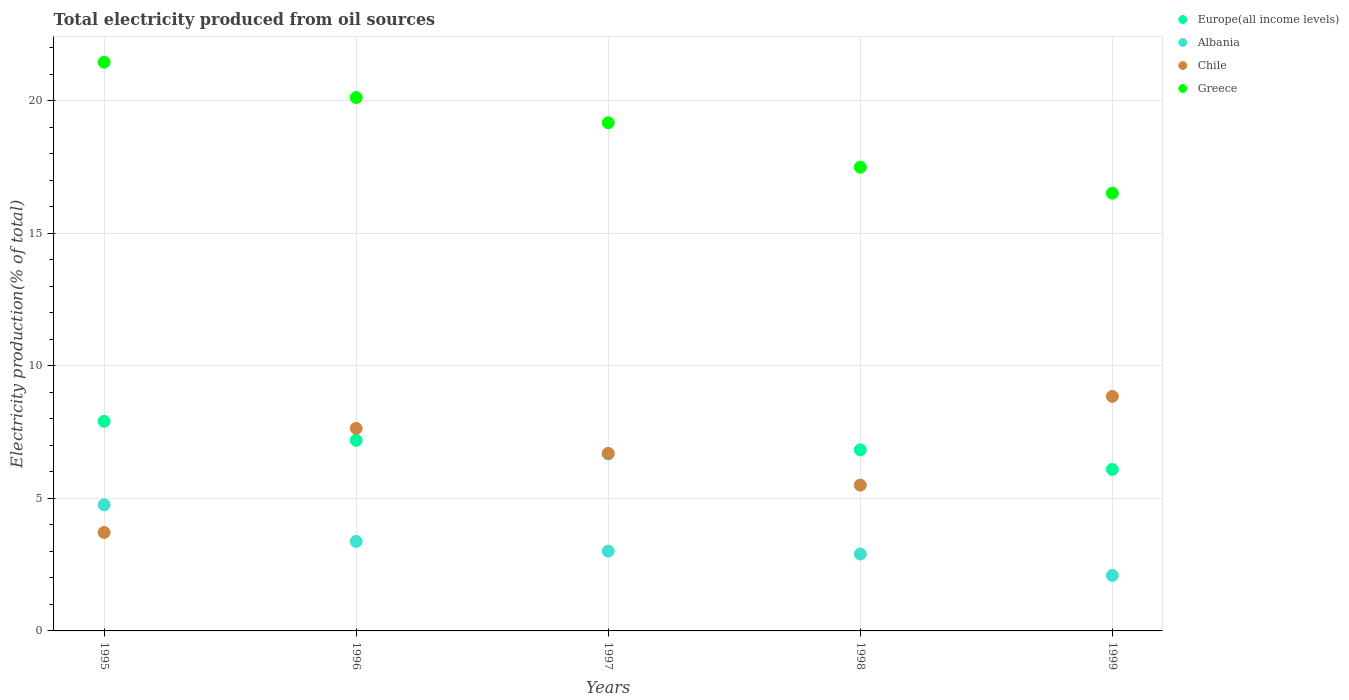Is the number of dotlines equal to the number of legend labels?
Offer a terse response. Yes. What is the total electricity produced in Albania in 1999?
Keep it short and to the point. 2.09. Across all years, what is the maximum total electricity produced in Greece?
Offer a terse response. 21.45. Across all years, what is the minimum total electricity produced in Europe(all income levels)?
Provide a succinct answer. 6.09. In which year was the total electricity produced in Chile minimum?
Offer a very short reply. 1995. What is the total total electricity produced in Albania in the graph?
Your answer should be very brief. 16.14. What is the difference between the total electricity produced in Greece in 1995 and that in 1997?
Ensure brevity in your answer.  2.28. What is the difference between the total electricity produced in Albania in 1998 and the total electricity produced in Europe(all income levels) in 1999?
Your response must be concise. -3.19. What is the average total electricity produced in Chile per year?
Your response must be concise. 6.48. In the year 1998, what is the difference between the total electricity produced in Greece and total electricity produced in Albania?
Make the answer very short. 14.59. In how many years, is the total electricity produced in Chile greater than 16 %?
Keep it short and to the point. 0. What is the ratio of the total electricity produced in Greece in 1995 to that in 1996?
Your answer should be compact. 1.07. Is the difference between the total electricity produced in Greece in 1995 and 1996 greater than the difference between the total electricity produced in Albania in 1995 and 1996?
Your answer should be compact. No. What is the difference between the highest and the second highest total electricity produced in Europe(all income levels)?
Provide a short and direct response. 0.72. What is the difference between the highest and the lowest total electricity produced in Albania?
Ensure brevity in your answer.  2.66. Is the sum of the total electricity produced in Albania in 1998 and 1999 greater than the maximum total electricity produced in Greece across all years?
Provide a short and direct response. No. Is it the case that in every year, the sum of the total electricity produced in Albania and total electricity produced in Europe(all income levels)  is greater than the total electricity produced in Chile?
Offer a very short reply. No. Is the total electricity produced in Albania strictly less than the total electricity produced in Chile over the years?
Give a very brief answer. No. How many dotlines are there?
Ensure brevity in your answer.  4. Does the graph contain grids?
Offer a terse response. Yes. How many legend labels are there?
Your answer should be very brief. 4. How are the legend labels stacked?
Your answer should be compact. Vertical. What is the title of the graph?
Provide a short and direct response. Total electricity produced from oil sources. Does "Tonga" appear as one of the legend labels in the graph?
Your answer should be very brief. No. What is the label or title of the Y-axis?
Give a very brief answer. Electricity production(% of total). What is the Electricity production(% of total) of Europe(all income levels) in 1995?
Make the answer very short. 7.91. What is the Electricity production(% of total) in Albania in 1995?
Your answer should be very brief. 4.76. What is the Electricity production(% of total) of Chile in 1995?
Ensure brevity in your answer.  3.71. What is the Electricity production(% of total) of Greece in 1995?
Provide a succinct answer. 21.45. What is the Electricity production(% of total) of Europe(all income levels) in 1996?
Make the answer very short. 7.19. What is the Electricity production(% of total) of Albania in 1996?
Keep it short and to the point. 3.37. What is the Electricity production(% of total) of Chile in 1996?
Offer a very short reply. 7.64. What is the Electricity production(% of total) in Greece in 1996?
Offer a terse response. 20.12. What is the Electricity production(% of total) of Europe(all income levels) in 1997?
Your response must be concise. 6.68. What is the Electricity production(% of total) of Albania in 1997?
Ensure brevity in your answer.  3.01. What is the Electricity production(% of total) in Chile in 1997?
Offer a very short reply. 6.7. What is the Electricity production(% of total) in Greece in 1997?
Offer a very short reply. 19.17. What is the Electricity production(% of total) of Europe(all income levels) in 1998?
Offer a very short reply. 6.83. What is the Electricity production(% of total) in Albania in 1998?
Keep it short and to the point. 2.9. What is the Electricity production(% of total) of Chile in 1998?
Offer a very short reply. 5.5. What is the Electricity production(% of total) of Greece in 1998?
Make the answer very short. 17.49. What is the Electricity production(% of total) in Europe(all income levels) in 1999?
Your answer should be very brief. 6.09. What is the Electricity production(% of total) in Albania in 1999?
Ensure brevity in your answer.  2.09. What is the Electricity production(% of total) in Chile in 1999?
Keep it short and to the point. 8.85. What is the Electricity production(% of total) in Greece in 1999?
Provide a short and direct response. 16.51. Across all years, what is the maximum Electricity production(% of total) in Europe(all income levels)?
Make the answer very short. 7.91. Across all years, what is the maximum Electricity production(% of total) of Albania?
Your answer should be very brief. 4.76. Across all years, what is the maximum Electricity production(% of total) of Chile?
Offer a terse response. 8.85. Across all years, what is the maximum Electricity production(% of total) in Greece?
Ensure brevity in your answer.  21.45. Across all years, what is the minimum Electricity production(% of total) in Europe(all income levels)?
Ensure brevity in your answer.  6.09. Across all years, what is the minimum Electricity production(% of total) in Albania?
Offer a terse response. 2.09. Across all years, what is the minimum Electricity production(% of total) in Chile?
Make the answer very short. 3.71. Across all years, what is the minimum Electricity production(% of total) of Greece?
Give a very brief answer. 16.51. What is the total Electricity production(% of total) in Europe(all income levels) in the graph?
Ensure brevity in your answer.  34.7. What is the total Electricity production(% of total) of Albania in the graph?
Offer a terse response. 16.14. What is the total Electricity production(% of total) of Chile in the graph?
Your response must be concise. 32.4. What is the total Electricity production(% of total) in Greece in the graph?
Your answer should be compact. 94.75. What is the difference between the Electricity production(% of total) of Europe(all income levels) in 1995 and that in 1996?
Give a very brief answer. 0.72. What is the difference between the Electricity production(% of total) of Albania in 1995 and that in 1996?
Ensure brevity in your answer.  1.38. What is the difference between the Electricity production(% of total) of Chile in 1995 and that in 1996?
Keep it short and to the point. -3.93. What is the difference between the Electricity production(% of total) in Greece in 1995 and that in 1996?
Ensure brevity in your answer.  1.33. What is the difference between the Electricity production(% of total) of Europe(all income levels) in 1995 and that in 1997?
Offer a very short reply. 1.22. What is the difference between the Electricity production(% of total) in Albania in 1995 and that in 1997?
Keep it short and to the point. 1.75. What is the difference between the Electricity production(% of total) in Chile in 1995 and that in 1997?
Your answer should be compact. -2.98. What is the difference between the Electricity production(% of total) in Greece in 1995 and that in 1997?
Your answer should be compact. 2.28. What is the difference between the Electricity production(% of total) in Europe(all income levels) in 1995 and that in 1998?
Ensure brevity in your answer.  1.08. What is the difference between the Electricity production(% of total) of Albania in 1995 and that in 1998?
Your answer should be very brief. 1.86. What is the difference between the Electricity production(% of total) in Chile in 1995 and that in 1998?
Provide a succinct answer. -1.79. What is the difference between the Electricity production(% of total) in Greece in 1995 and that in 1998?
Offer a very short reply. 3.96. What is the difference between the Electricity production(% of total) of Europe(all income levels) in 1995 and that in 1999?
Your answer should be very brief. 1.82. What is the difference between the Electricity production(% of total) of Albania in 1995 and that in 1999?
Ensure brevity in your answer.  2.66. What is the difference between the Electricity production(% of total) of Chile in 1995 and that in 1999?
Offer a very short reply. -5.13. What is the difference between the Electricity production(% of total) in Greece in 1995 and that in 1999?
Your answer should be compact. 4.94. What is the difference between the Electricity production(% of total) in Europe(all income levels) in 1996 and that in 1997?
Your answer should be compact. 0.51. What is the difference between the Electricity production(% of total) in Albania in 1996 and that in 1997?
Your answer should be compact. 0.37. What is the difference between the Electricity production(% of total) in Chile in 1996 and that in 1997?
Your answer should be compact. 0.94. What is the difference between the Electricity production(% of total) of Greece in 1996 and that in 1997?
Your response must be concise. 0.95. What is the difference between the Electricity production(% of total) of Europe(all income levels) in 1996 and that in 1998?
Ensure brevity in your answer.  0.36. What is the difference between the Electricity production(% of total) of Albania in 1996 and that in 1998?
Offer a terse response. 0.47. What is the difference between the Electricity production(% of total) in Chile in 1996 and that in 1998?
Give a very brief answer. 2.14. What is the difference between the Electricity production(% of total) in Greece in 1996 and that in 1998?
Your answer should be very brief. 2.63. What is the difference between the Electricity production(% of total) in Europe(all income levels) in 1996 and that in 1999?
Your answer should be very brief. 1.1. What is the difference between the Electricity production(% of total) in Albania in 1996 and that in 1999?
Your answer should be compact. 1.28. What is the difference between the Electricity production(% of total) of Chile in 1996 and that in 1999?
Keep it short and to the point. -1.21. What is the difference between the Electricity production(% of total) of Greece in 1996 and that in 1999?
Your answer should be very brief. 3.61. What is the difference between the Electricity production(% of total) of Europe(all income levels) in 1997 and that in 1998?
Your response must be concise. -0.15. What is the difference between the Electricity production(% of total) of Albania in 1997 and that in 1998?
Your answer should be very brief. 0.11. What is the difference between the Electricity production(% of total) in Chile in 1997 and that in 1998?
Your answer should be very brief. 1.2. What is the difference between the Electricity production(% of total) of Greece in 1997 and that in 1998?
Offer a terse response. 1.68. What is the difference between the Electricity production(% of total) in Europe(all income levels) in 1997 and that in 1999?
Make the answer very short. 0.59. What is the difference between the Electricity production(% of total) in Albania in 1997 and that in 1999?
Ensure brevity in your answer.  0.92. What is the difference between the Electricity production(% of total) in Chile in 1997 and that in 1999?
Ensure brevity in your answer.  -2.15. What is the difference between the Electricity production(% of total) in Greece in 1997 and that in 1999?
Your answer should be very brief. 2.66. What is the difference between the Electricity production(% of total) in Europe(all income levels) in 1998 and that in 1999?
Your answer should be compact. 0.74. What is the difference between the Electricity production(% of total) in Albania in 1998 and that in 1999?
Provide a succinct answer. 0.81. What is the difference between the Electricity production(% of total) of Chile in 1998 and that in 1999?
Your answer should be very brief. -3.35. What is the difference between the Electricity production(% of total) in Greece in 1998 and that in 1999?
Provide a short and direct response. 0.98. What is the difference between the Electricity production(% of total) of Europe(all income levels) in 1995 and the Electricity production(% of total) of Albania in 1996?
Provide a succinct answer. 4.53. What is the difference between the Electricity production(% of total) in Europe(all income levels) in 1995 and the Electricity production(% of total) in Chile in 1996?
Make the answer very short. 0.27. What is the difference between the Electricity production(% of total) of Europe(all income levels) in 1995 and the Electricity production(% of total) of Greece in 1996?
Your response must be concise. -12.22. What is the difference between the Electricity production(% of total) in Albania in 1995 and the Electricity production(% of total) in Chile in 1996?
Make the answer very short. -2.88. What is the difference between the Electricity production(% of total) in Albania in 1995 and the Electricity production(% of total) in Greece in 1996?
Your answer should be compact. -15.36. What is the difference between the Electricity production(% of total) of Chile in 1995 and the Electricity production(% of total) of Greece in 1996?
Your response must be concise. -16.41. What is the difference between the Electricity production(% of total) in Europe(all income levels) in 1995 and the Electricity production(% of total) in Albania in 1997?
Offer a terse response. 4.9. What is the difference between the Electricity production(% of total) of Europe(all income levels) in 1995 and the Electricity production(% of total) of Chile in 1997?
Your response must be concise. 1.21. What is the difference between the Electricity production(% of total) of Europe(all income levels) in 1995 and the Electricity production(% of total) of Greece in 1997?
Keep it short and to the point. -11.26. What is the difference between the Electricity production(% of total) of Albania in 1995 and the Electricity production(% of total) of Chile in 1997?
Provide a short and direct response. -1.94. What is the difference between the Electricity production(% of total) in Albania in 1995 and the Electricity production(% of total) in Greece in 1997?
Make the answer very short. -14.41. What is the difference between the Electricity production(% of total) in Chile in 1995 and the Electricity production(% of total) in Greece in 1997?
Make the answer very short. -15.46. What is the difference between the Electricity production(% of total) of Europe(all income levels) in 1995 and the Electricity production(% of total) of Albania in 1998?
Your answer should be very brief. 5.01. What is the difference between the Electricity production(% of total) of Europe(all income levels) in 1995 and the Electricity production(% of total) of Chile in 1998?
Give a very brief answer. 2.41. What is the difference between the Electricity production(% of total) of Europe(all income levels) in 1995 and the Electricity production(% of total) of Greece in 1998?
Provide a succinct answer. -9.59. What is the difference between the Electricity production(% of total) of Albania in 1995 and the Electricity production(% of total) of Chile in 1998?
Ensure brevity in your answer.  -0.74. What is the difference between the Electricity production(% of total) in Albania in 1995 and the Electricity production(% of total) in Greece in 1998?
Your response must be concise. -12.73. What is the difference between the Electricity production(% of total) of Chile in 1995 and the Electricity production(% of total) of Greece in 1998?
Ensure brevity in your answer.  -13.78. What is the difference between the Electricity production(% of total) in Europe(all income levels) in 1995 and the Electricity production(% of total) in Albania in 1999?
Make the answer very short. 5.81. What is the difference between the Electricity production(% of total) in Europe(all income levels) in 1995 and the Electricity production(% of total) in Chile in 1999?
Provide a succinct answer. -0.94. What is the difference between the Electricity production(% of total) in Europe(all income levels) in 1995 and the Electricity production(% of total) in Greece in 1999?
Give a very brief answer. -8.61. What is the difference between the Electricity production(% of total) of Albania in 1995 and the Electricity production(% of total) of Chile in 1999?
Ensure brevity in your answer.  -4.09. What is the difference between the Electricity production(% of total) in Albania in 1995 and the Electricity production(% of total) in Greece in 1999?
Give a very brief answer. -11.76. What is the difference between the Electricity production(% of total) of Chile in 1995 and the Electricity production(% of total) of Greece in 1999?
Offer a terse response. -12.8. What is the difference between the Electricity production(% of total) of Europe(all income levels) in 1996 and the Electricity production(% of total) of Albania in 1997?
Your answer should be very brief. 4.18. What is the difference between the Electricity production(% of total) in Europe(all income levels) in 1996 and the Electricity production(% of total) in Chile in 1997?
Give a very brief answer. 0.49. What is the difference between the Electricity production(% of total) of Europe(all income levels) in 1996 and the Electricity production(% of total) of Greece in 1997?
Keep it short and to the point. -11.98. What is the difference between the Electricity production(% of total) of Albania in 1996 and the Electricity production(% of total) of Chile in 1997?
Offer a terse response. -3.32. What is the difference between the Electricity production(% of total) of Albania in 1996 and the Electricity production(% of total) of Greece in 1997?
Offer a terse response. -15.79. What is the difference between the Electricity production(% of total) in Chile in 1996 and the Electricity production(% of total) in Greece in 1997?
Keep it short and to the point. -11.53. What is the difference between the Electricity production(% of total) of Europe(all income levels) in 1996 and the Electricity production(% of total) of Albania in 1998?
Provide a succinct answer. 4.29. What is the difference between the Electricity production(% of total) of Europe(all income levels) in 1996 and the Electricity production(% of total) of Chile in 1998?
Offer a very short reply. 1.69. What is the difference between the Electricity production(% of total) in Europe(all income levels) in 1996 and the Electricity production(% of total) in Greece in 1998?
Your answer should be very brief. -10.3. What is the difference between the Electricity production(% of total) of Albania in 1996 and the Electricity production(% of total) of Chile in 1998?
Offer a very short reply. -2.13. What is the difference between the Electricity production(% of total) in Albania in 1996 and the Electricity production(% of total) in Greece in 1998?
Your answer should be compact. -14.12. What is the difference between the Electricity production(% of total) in Chile in 1996 and the Electricity production(% of total) in Greece in 1998?
Make the answer very short. -9.85. What is the difference between the Electricity production(% of total) in Europe(all income levels) in 1996 and the Electricity production(% of total) in Albania in 1999?
Offer a very short reply. 5.1. What is the difference between the Electricity production(% of total) of Europe(all income levels) in 1996 and the Electricity production(% of total) of Chile in 1999?
Offer a very short reply. -1.66. What is the difference between the Electricity production(% of total) of Europe(all income levels) in 1996 and the Electricity production(% of total) of Greece in 1999?
Your answer should be very brief. -9.32. What is the difference between the Electricity production(% of total) of Albania in 1996 and the Electricity production(% of total) of Chile in 1999?
Your answer should be compact. -5.47. What is the difference between the Electricity production(% of total) in Albania in 1996 and the Electricity production(% of total) in Greece in 1999?
Provide a short and direct response. -13.14. What is the difference between the Electricity production(% of total) of Chile in 1996 and the Electricity production(% of total) of Greece in 1999?
Your answer should be very brief. -8.87. What is the difference between the Electricity production(% of total) of Europe(all income levels) in 1997 and the Electricity production(% of total) of Albania in 1998?
Ensure brevity in your answer.  3.78. What is the difference between the Electricity production(% of total) of Europe(all income levels) in 1997 and the Electricity production(% of total) of Chile in 1998?
Ensure brevity in your answer.  1.18. What is the difference between the Electricity production(% of total) in Europe(all income levels) in 1997 and the Electricity production(% of total) in Greece in 1998?
Your answer should be very brief. -10.81. What is the difference between the Electricity production(% of total) of Albania in 1997 and the Electricity production(% of total) of Chile in 1998?
Ensure brevity in your answer.  -2.49. What is the difference between the Electricity production(% of total) of Albania in 1997 and the Electricity production(% of total) of Greece in 1998?
Make the answer very short. -14.48. What is the difference between the Electricity production(% of total) of Chile in 1997 and the Electricity production(% of total) of Greece in 1998?
Offer a very short reply. -10.8. What is the difference between the Electricity production(% of total) of Europe(all income levels) in 1997 and the Electricity production(% of total) of Albania in 1999?
Offer a very short reply. 4.59. What is the difference between the Electricity production(% of total) in Europe(all income levels) in 1997 and the Electricity production(% of total) in Chile in 1999?
Offer a very short reply. -2.17. What is the difference between the Electricity production(% of total) of Europe(all income levels) in 1997 and the Electricity production(% of total) of Greece in 1999?
Provide a succinct answer. -9.83. What is the difference between the Electricity production(% of total) of Albania in 1997 and the Electricity production(% of total) of Chile in 1999?
Your answer should be compact. -5.84. What is the difference between the Electricity production(% of total) in Albania in 1997 and the Electricity production(% of total) in Greece in 1999?
Offer a terse response. -13.5. What is the difference between the Electricity production(% of total) in Chile in 1997 and the Electricity production(% of total) in Greece in 1999?
Give a very brief answer. -9.82. What is the difference between the Electricity production(% of total) in Europe(all income levels) in 1998 and the Electricity production(% of total) in Albania in 1999?
Keep it short and to the point. 4.74. What is the difference between the Electricity production(% of total) of Europe(all income levels) in 1998 and the Electricity production(% of total) of Chile in 1999?
Your response must be concise. -2.02. What is the difference between the Electricity production(% of total) in Europe(all income levels) in 1998 and the Electricity production(% of total) in Greece in 1999?
Your response must be concise. -9.68. What is the difference between the Electricity production(% of total) in Albania in 1998 and the Electricity production(% of total) in Chile in 1999?
Your answer should be very brief. -5.95. What is the difference between the Electricity production(% of total) of Albania in 1998 and the Electricity production(% of total) of Greece in 1999?
Provide a succinct answer. -13.61. What is the difference between the Electricity production(% of total) in Chile in 1998 and the Electricity production(% of total) in Greece in 1999?
Your answer should be very brief. -11.01. What is the average Electricity production(% of total) of Europe(all income levels) per year?
Your answer should be compact. 6.94. What is the average Electricity production(% of total) of Albania per year?
Provide a short and direct response. 3.23. What is the average Electricity production(% of total) in Chile per year?
Provide a succinct answer. 6.48. What is the average Electricity production(% of total) of Greece per year?
Provide a short and direct response. 18.95. In the year 1995, what is the difference between the Electricity production(% of total) of Europe(all income levels) and Electricity production(% of total) of Albania?
Your answer should be compact. 3.15. In the year 1995, what is the difference between the Electricity production(% of total) in Europe(all income levels) and Electricity production(% of total) in Chile?
Provide a short and direct response. 4.19. In the year 1995, what is the difference between the Electricity production(% of total) in Europe(all income levels) and Electricity production(% of total) in Greece?
Provide a short and direct response. -13.55. In the year 1995, what is the difference between the Electricity production(% of total) in Albania and Electricity production(% of total) in Chile?
Your answer should be very brief. 1.04. In the year 1995, what is the difference between the Electricity production(% of total) of Albania and Electricity production(% of total) of Greece?
Give a very brief answer. -16.7. In the year 1995, what is the difference between the Electricity production(% of total) of Chile and Electricity production(% of total) of Greece?
Make the answer very short. -17.74. In the year 1996, what is the difference between the Electricity production(% of total) in Europe(all income levels) and Electricity production(% of total) in Albania?
Provide a short and direct response. 3.81. In the year 1996, what is the difference between the Electricity production(% of total) of Europe(all income levels) and Electricity production(% of total) of Chile?
Give a very brief answer. -0.45. In the year 1996, what is the difference between the Electricity production(% of total) of Europe(all income levels) and Electricity production(% of total) of Greece?
Your response must be concise. -12.93. In the year 1996, what is the difference between the Electricity production(% of total) in Albania and Electricity production(% of total) in Chile?
Your response must be concise. -4.26. In the year 1996, what is the difference between the Electricity production(% of total) in Albania and Electricity production(% of total) in Greece?
Make the answer very short. -16.75. In the year 1996, what is the difference between the Electricity production(% of total) in Chile and Electricity production(% of total) in Greece?
Give a very brief answer. -12.48. In the year 1997, what is the difference between the Electricity production(% of total) of Europe(all income levels) and Electricity production(% of total) of Albania?
Provide a succinct answer. 3.67. In the year 1997, what is the difference between the Electricity production(% of total) of Europe(all income levels) and Electricity production(% of total) of Chile?
Offer a terse response. -0.02. In the year 1997, what is the difference between the Electricity production(% of total) in Europe(all income levels) and Electricity production(% of total) in Greece?
Offer a terse response. -12.49. In the year 1997, what is the difference between the Electricity production(% of total) of Albania and Electricity production(% of total) of Chile?
Give a very brief answer. -3.69. In the year 1997, what is the difference between the Electricity production(% of total) in Albania and Electricity production(% of total) in Greece?
Give a very brief answer. -16.16. In the year 1997, what is the difference between the Electricity production(% of total) in Chile and Electricity production(% of total) in Greece?
Give a very brief answer. -12.47. In the year 1998, what is the difference between the Electricity production(% of total) in Europe(all income levels) and Electricity production(% of total) in Albania?
Give a very brief answer. 3.93. In the year 1998, what is the difference between the Electricity production(% of total) of Europe(all income levels) and Electricity production(% of total) of Chile?
Provide a short and direct response. 1.33. In the year 1998, what is the difference between the Electricity production(% of total) in Europe(all income levels) and Electricity production(% of total) in Greece?
Provide a succinct answer. -10.66. In the year 1998, what is the difference between the Electricity production(% of total) of Albania and Electricity production(% of total) of Chile?
Your answer should be very brief. -2.6. In the year 1998, what is the difference between the Electricity production(% of total) of Albania and Electricity production(% of total) of Greece?
Offer a terse response. -14.59. In the year 1998, what is the difference between the Electricity production(% of total) in Chile and Electricity production(% of total) in Greece?
Your answer should be very brief. -11.99. In the year 1999, what is the difference between the Electricity production(% of total) in Europe(all income levels) and Electricity production(% of total) in Albania?
Your answer should be very brief. 4. In the year 1999, what is the difference between the Electricity production(% of total) in Europe(all income levels) and Electricity production(% of total) in Chile?
Your response must be concise. -2.76. In the year 1999, what is the difference between the Electricity production(% of total) in Europe(all income levels) and Electricity production(% of total) in Greece?
Keep it short and to the point. -10.42. In the year 1999, what is the difference between the Electricity production(% of total) in Albania and Electricity production(% of total) in Chile?
Keep it short and to the point. -6.75. In the year 1999, what is the difference between the Electricity production(% of total) of Albania and Electricity production(% of total) of Greece?
Offer a very short reply. -14.42. In the year 1999, what is the difference between the Electricity production(% of total) in Chile and Electricity production(% of total) in Greece?
Give a very brief answer. -7.67. What is the ratio of the Electricity production(% of total) in Europe(all income levels) in 1995 to that in 1996?
Offer a very short reply. 1.1. What is the ratio of the Electricity production(% of total) in Albania in 1995 to that in 1996?
Provide a short and direct response. 1.41. What is the ratio of the Electricity production(% of total) of Chile in 1995 to that in 1996?
Your answer should be compact. 0.49. What is the ratio of the Electricity production(% of total) of Greece in 1995 to that in 1996?
Your answer should be compact. 1.07. What is the ratio of the Electricity production(% of total) in Europe(all income levels) in 1995 to that in 1997?
Your answer should be compact. 1.18. What is the ratio of the Electricity production(% of total) in Albania in 1995 to that in 1997?
Give a very brief answer. 1.58. What is the ratio of the Electricity production(% of total) in Chile in 1995 to that in 1997?
Keep it short and to the point. 0.55. What is the ratio of the Electricity production(% of total) in Greece in 1995 to that in 1997?
Your answer should be very brief. 1.12. What is the ratio of the Electricity production(% of total) of Europe(all income levels) in 1995 to that in 1998?
Make the answer very short. 1.16. What is the ratio of the Electricity production(% of total) of Albania in 1995 to that in 1998?
Provide a succinct answer. 1.64. What is the ratio of the Electricity production(% of total) of Chile in 1995 to that in 1998?
Give a very brief answer. 0.68. What is the ratio of the Electricity production(% of total) in Greece in 1995 to that in 1998?
Your response must be concise. 1.23. What is the ratio of the Electricity production(% of total) of Europe(all income levels) in 1995 to that in 1999?
Keep it short and to the point. 1.3. What is the ratio of the Electricity production(% of total) of Albania in 1995 to that in 1999?
Give a very brief answer. 2.27. What is the ratio of the Electricity production(% of total) of Chile in 1995 to that in 1999?
Keep it short and to the point. 0.42. What is the ratio of the Electricity production(% of total) in Greece in 1995 to that in 1999?
Keep it short and to the point. 1.3. What is the ratio of the Electricity production(% of total) of Europe(all income levels) in 1996 to that in 1997?
Your answer should be compact. 1.08. What is the ratio of the Electricity production(% of total) in Albania in 1996 to that in 1997?
Provide a succinct answer. 1.12. What is the ratio of the Electricity production(% of total) of Chile in 1996 to that in 1997?
Offer a terse response. 1.14. What is the ratio of the Electricity production(% of total) of Greece in 1996 to that in 1997?
Your answer should be compact. 1.05. What is the ratio of the Electricity production(% of total) of Europe(all income levels) in 1996 to that in 1998?
Keep it short and to the point. 1.05. What is the ratio of the Electricity production(% of total) in Albania in 1996 to that in 1998?
Provide a short and direct response. 1.16. What is the ratio of the Electricity production(% of total) in Chile in 1996 to that in 1998?
Your answer should be compact. 1.39. What is the ratio of the Electricity production(% of total) of Greece in 1996 to that in 1998?
Offer a terse response. 1.15. What is the ratio of the Electricity production(% of total) of Europe(all income levels) in 1996 to that in 1999?
Keep it short and to the point. 1.18. What is the ratio of the Electricity production(% of total) in Albania in 1996 to that in 1999?
Give a very brief answer. 1.61. What is the ratio of the Electricity production(% of total) of Chile in 1996 to that in 1999?
Keep it short and to the point. 0.86. What is the ratio of the Electricity production(% of total) in Greece in 1996 to that in 1999?
Your response must be concise. 1.22. What is the ratio of the Electricity production(% of total) of Europe(all income levels) in 1997 to that in 1998?
Your response must be concise. 0.98. What is the ratio of the Electricity production(% of total) of Albania in 1997 to that in 1998?
Give a very brief answer. 1.04. What is the ratio of the Electricity production(% of total) in Chile in 1997 to that in 1998?
Your answer should be compact. 1.22. What is the ratio of the Electricity production(% of total) in Greece in 1997 to that in 1998?
Offer a very short reply. 1.1. What is the ratio of the Electricity production(% of total) in Europe(all income levels) in 1997 to that in 1999?
Your answer should be compact. 1.1. What is the ratio of the Electricity production(% of total) of Albania in 1997 to that in 1999?
Offer a terse response. 1.44. What is the ratio of the Electricity production(% of total) of Chile in 1997 to that in 1999?
Your answer should be very brief. 0.76. What is the ratio of the Electricity production(% of total) of Greece in 1997 to that in 1999?
Keep it short and to the point. 1.16. What is the ratio of the Electricity production(% of total) in Europe(all income levels) in 1998 to that in 1999?
Ensure brevity in your answer.  1.12. What is the ratio of the Electricity production(% of total) of Albania in 1998 to that in 1999?
Give a very brief answer. 1.39. What is the ratio of the Electricity production(% of total) of Chile in 1998 to that in 1999?
Your answer should be compact. 0.62. What is the ratio of the Electricity production(% of total) in Greece in 1998 to that in 1999?
Your answer should be compact. 1.06. What is the difference between the highest and the second highest Electricity production(% of total) of Europe(all income levels)?
Ensure brevity in your answer.  0.72. What is the difference between the highest and the second highest Electricity production(% of total) in Albania?
Give a very brief answer. 1.38. What is the difference between the highest and the second highest Electricity production(% of total) of Chile?
Make the answer very short. 1.21. What is the difference between the highest and the second highest Electricity production(% of total) of Greece?
Provide a short and direct response. 1.33. What is the difference between the highest and the lowest Electricity production(% of total) of Europe(all income levels)?
Provide a short and direct response. 1.82. What is the difference between the highest and the lowest Electricity production(% of total) in Albania?
Offer a terse response. 2.66. What is the difference between the highest and the lowest Electricity production(% of total) of Chile?
Give a very brief answer. 5.13. What is the difference between the highest and the lowest Electricity production(% of total) of Greece?
Ensure brevity in your answer.  4.94. 